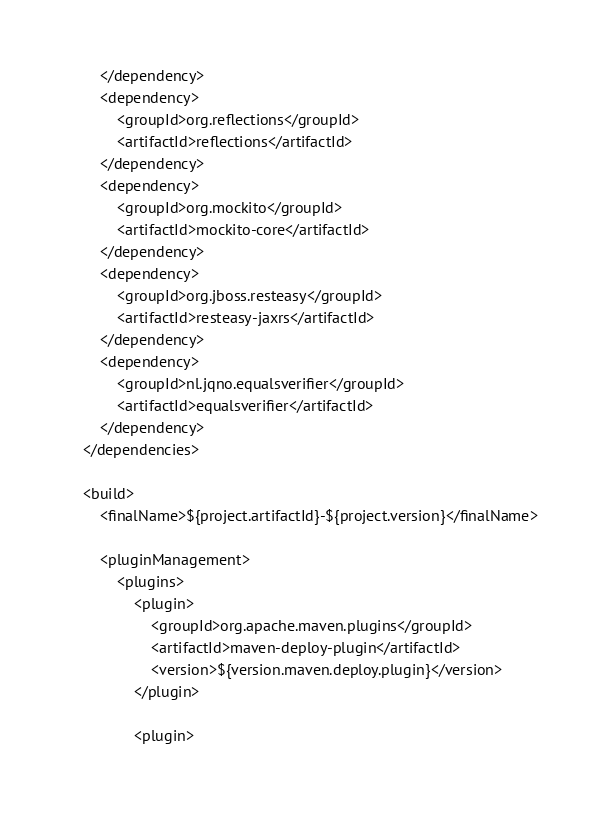Convert code to text. <code><loc_0><loc_0><loc_500><loc_500><_XML_>        </dependency>
        <dependency>
            <groupId>org.reflections</groupId>
            <artifactId>reflections</artifactId>
        </dependency>
        <dependency>
            <groupId>org.mockito</groupId>
            <artifactId>mockito-core</artifactId>
        </dependency>
        <dependency>
            <groupId>org.jboss.resteasy</groupId>
            <artifactId>resteasy-jaxrs</artifactId>
        </dependency>
        <dependency>
            <groupId>nl.jqno.equalsverifier</groupId>
            <artifactId>equalsverifier</artifactId>
        </dependency>
    </dependencies>

    <build>
        <finalName>${project.artifactId}-${project.version}</finalName>

        <pluginManagement>
            <plugins>
                <plugin>
                    <groupId>org.apache.maven.plugins</groupId>
                    <artifactId>maven-deploy-plugin</artifactId>
                    <version>${version.maven.deploy.plugin}</version>
                </plugin>

                <plugin></code> 